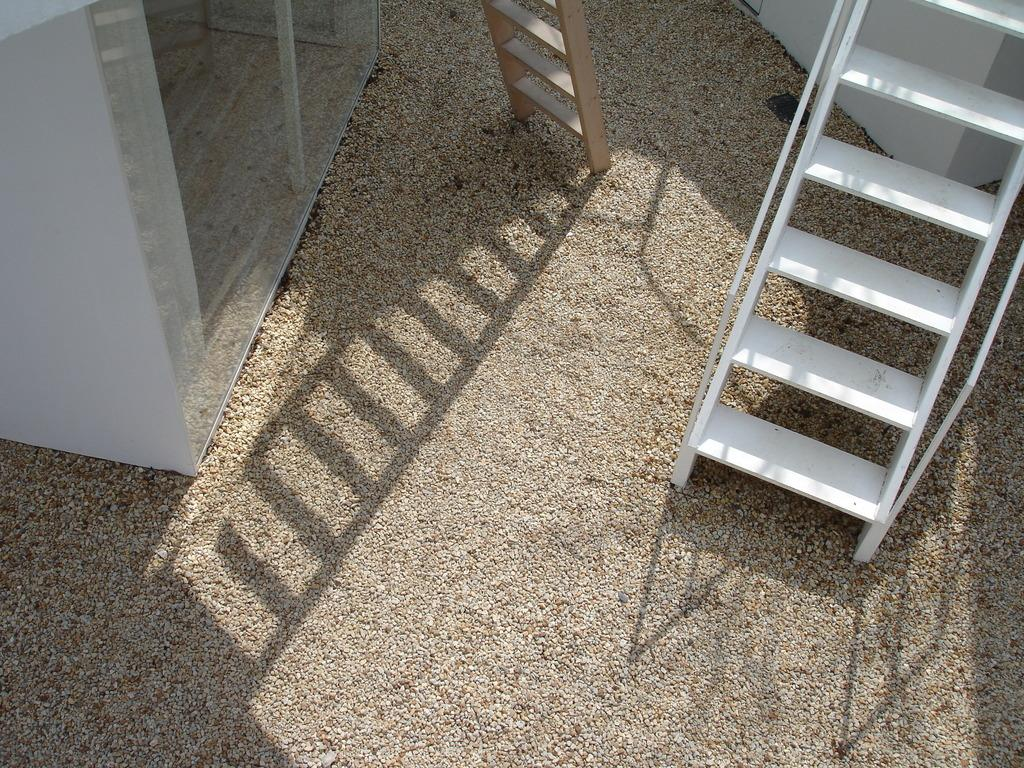What type of structure is present in the image? There is a staircase and a ladder in the image. What type of material is used for the window in the image? There is a glass window in the image. What type of surface is present in the image? The bottom and center of the image consists of sand. What type of architectural feature is present in the image? There is a wall in the image. What shape is the horn that is being played in the image? There is no horn present in the image. What type of jelly is being used to decorate the wall in the image? There is no jelly present in the image; it features a wall, a staircase, a ladder, a glass window, and sand. 